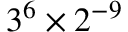<formula> <loc_0><loc_0><loc_500><loc_500>3 ^ { 6 } \times 2 ^ { - 9 }</formula> 